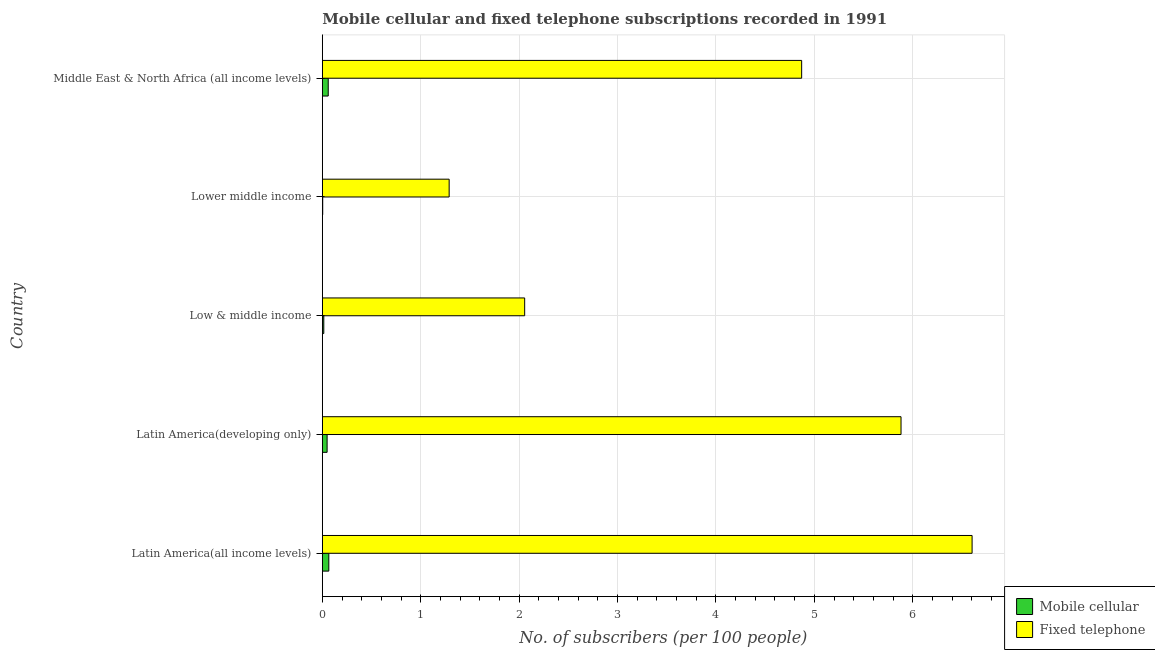How many different coloured bars are there?
Provide a short and direct response. 2. Are the number of bars per tick equal to the number of legend labels?
Provide a succinct answer. Yes. Are the number of bars on each tick of the Y-axis equal?
Provide a short and direct response. Yes. How many bars are there on the 2nd tick from the top?
Keep it short and to the point. 2. What is the label of the 1st group of bars from the top?
Provide a short and direct response. Middle East & North Africa (all income levels). In how many cases, is the number of bars for a given country not equal to the number of legend labels?
Ensure brevity in your answer.  0. What is the number of mobile cellular subscribers in Lower middle income?
Make the answer very short. 0. Across all countries, what is the maximum number of mobile cellular subscribers?
Provide a short and direct response. 0.07. Across all countries, what is the minimum number of mobile cellular subscribers?
Keep it short and to the point. 0. In which country was the number of fixed telephone subscribers maximum?
Give a very brief answer. Latin America(all income levels). In which country was the number of mobile cellular subscribers minimum?
Offer a very short reply. Lower middle income. What is the total number of fixed telephone subscribers in the graph?
Provide a succinct answer. 20.7. What is the difference between the number of mobile cellular subscribers in Latin America(all income levels) and that in Middle East & North Africa (all income levels)?
Your answer should be very brief. 0.01. What is the difference between the number of fixed telephone subscribers in Middle East & North Africa (all income levels) and the number of mobile cellular subscribers in Latin America(all income levels)?
Offer a terse response. 4.81. What is the average number of fixed telephone subscribers per country?
Keep it short and to the point. 4.14. What is the difference between the number of mobile cellular subscribers and number of fixed telephone subscribers in Latin America(all income levels)?
Offer a terse response. -6.54. In how many countries, is the number of fixed telephone subscribers greater than 6 ?
Ensure brevity in your answer.  1. What is the ratio of the number of mobile cellular subscribers in Latin America(developing only) to that in Lower middle income?
Your answer should be very brief. 12.28. Is the difference between the number of mobile cellular subscribers in Low & middle income and Middle East & North Africa (all income levels) greater than the difference between the number of fixed telephone subscribers in Low & middle income and Middle East & North Africa (all income levels)?
Your answer should be compact. Yes. What is the difference between the highest and the second highest number of mobile cellular subscribers?
Offer a terse response. 0.01. In how many countries, is the number of mobile cellular subscribers greater than the average number of mobile cellular subscribers taken over all countries?
Provide a short and direct response. 3. What does the 2nd bar from the top in Latin America(developing only) represents?
Keep it short and to the point. Mobile cellular. What does the 1st bar from the bottom in Low & middle income represents?
Provide a succinct answer. Mobile cellular. How many bars are there?
Provide a succinct answer. 10. What is the difference between two consecutive major ticks on the X-axis?
Keep it short and to the point. 1. Are the values on the major ticks of X-axis written in scientific E-notation?
Ensure brevity in your answer.  No. Where does the legend appear in the graph?
Make the answer very short. Bottom right. What is the title of the graph?
Offer a very short reply. Mobile cellular and fixed telephone subscriptions recorded in 1991. Does "Researchers" appear as one of the legend labels in the graph?
Your answer should be compact. No. What is the label or title of the X-axis?
Provide a short and direct response. No. of subscribers (per 100 people). What is the No. of subscribers (per 100 people) in Mobile cellular in Latin America(all income levels)?
Offer a very short reply. 0.07. What is the No. of subscribers (per 100 people) in Fixed telephone in Latin America(all income levels)?
Give a very brief answer. 6.6. What is the No. of subscribers (per 100 people) of Mobile cellular in Latin America(developing only)?
Provide a succinct answer. 0.05. What is the No. of subscribers (per 100 people) of Fixed telephone in Latin America(developing only)?
Ensure brevity in your answer.  5.88. What is the No. of subscribers (per 100 people) in Mobile cellular in Low & middle income?
Make the answer very short. 0.01. What is the No. of subscribers (per 100 people) in Fixed telephone in Low & middle income?
Provide a short and direct response. 2.06. What is the No. of subscribers (per 100 people) in Mobile cellular in Lower middle income?
Your response must be concise. 0. What is the No. of subscribers (per 100 people) in Fixed telephone in Lower middle income?
Make the answer very short. 1.29. What is the No. of subscribers (per 100 people) in Mobile cellular in Middle East & North Africa (all income levels)?
Your answer should be very brief. 0.06. What is the No. of subscribers (per 100 people) in Fixed telephone in Middle East & North Africa (all income levels)?
Offer a very short reply. 4.87. Across all countries, what is the maximum No. of subscribers (per 100 people) in Mobile cellular?
Your response must be concise. 0.07. Across all countries, what is the maximum No. of subscribers (per 100 people) in Fixed telephone?
Offer a very short reply. 6.6. Across all countries, what is the minimum No. of subscribers (per 100 people) of Mobile cellular?
Keep it short and to the point. 0. Across all countries, what is the minimum No. of subscribers (per 100 people) in Fixed telephone?
Give a very brief answer. 1.29. What is the total No. of subscribers (per 100 people) in Mobile cellular in the graph?
Make the answer very short. 0.19. What is the total No. of subscribers (per 100 people) of Fixed telephone in the graph?
Offer a terse response. 20.7. What is the difference between the No. of subscribers (per 100 people) in Mobile cellular in Latin America(all income levels) and that in Latin America(developing only)?
Your response must be concise. 0.02. What is the difference between the No. of subscribers (per 100 people) in Fixed telephone in Latin America(all income levels) and that in Latin America(developing only)?
Provide a short and direct response. 0.72. What is the difference between the No. of subscribers (per 100 people) in Mobile cellular in Latin America(all income levels) and that in Low & middle income?
Offer a very short reply. 0.05. What is the difference between the No. of subscribers (per 100 people) in Fixed telephone in Latin America(all income levels) and that in Low & middle income?
Provide a succinct answer. 4.55. What is the difference between the No. of subscribers (per 100 people) in Mobile cellular in Latin America(all income levels) and that in Lower middle income?
Your response must be concise. 0.06. What is the difference between the No. of subscribers (per 100 people) of Fixed telephone in Latin America(all income levels) and that in Lower middle income?
Ensure brevity in your answer.  5.31. What is the difference between the No. of subscribers (per 100 people) of Mobile cellular in Latin America(all income levels) and that in Middle East & North Africa (all income levels)?
Keep it short and to the point. 0.01. What is the difference between the No. of subscribers (per 100 people) in Fixed telephone in Latin America(all income levels) and that in Middle East & North Africa (all income levels)?
Give a very brief answer. 1.73. What is the difference between the No. of subscribers (per 100 people) in Mobile cellular in Latin America(developing only) and that in Low & middle income?
Keep it short and to the point. 0.03. What is the difference between the No. of subscribers (per 100 people) in Fixed telephone in Latin America(developing only) and that in Low & middle income?
Your answer should be compact. 3.82. What is the difference between the No. of subscribers (per 100 people) in Mobile cellular in Latin America(developing only) and that in Lower middle income?
Give a very brief answer. 0.04. What is the difference between the No. of subscribers (per 100 people) of Fixed telephone in Latin America(developing only) and that in Lower middle income?
Your response must be concise. 4.59. What is the difference between the No. of subscribers (per 100 people) in Mobile cellular in Latin America(developing only) and that in Middle East & North Africa (all income levels)?
Your response must be concise. -0.01. What is the difference between the No. of subscribers (per 100 people) of Fixed telephone in Latin America(developing only) and that in Middle East & North Africa (all income levels)?
Provide a short and direct response. 1.01. What is the difference between the No. of subscribers (per 100 people) in Mobile cellular in Low & middle income and that in Lower middle income?
Give a very brief answer. 0.01. What is the difference between the No. of subscribers (per 100 people) of Fixed telephone in Low & middle income and that in Lower middle income?
Offer a terse response. 0.77. What is the difference between the No. of subscribers (per 100 people) of Mobile cellular in Low & middle income and that in Middle East & North Africa (all income levels)?
Make the answer very short. -0.05. What is the difference between the No. of subscribers (per 100 people) in Fixed telephone in Low & middle income and that in Middle East & North Africa (all income levels)?
Offer a terse response. -2.81. What is the difference between the No. of subscribers (per 100 people) of Mobile cellular in Lower middle income and that in Middle East & North Africa (all income levels)?
Provide a succinct answer. -0.06. What is the difference between the No. of subscribers (per 100 people) of Fixed telephone in Lower middle income and that in Middle East & North Africa (all income levels)?
Your response must be concise. -3.58. What is the difference between the No. of subscribers (per 100 people) of Mobile cellular in Latin America(all income levels) and the No. of subscribers (per 100 people) of Fixed telephone in Latin America(developing only)?
Your response must be concise. -5.82. What is the difference between the No. of subscribers (per 100 people) in Mobile cellular in Latin America(all income levels) and the No. of subscribers (per 100 people) in Fixed telephone in Low & middle income?
Make the answer very short. -1.99. What is the difference between the No. of subscribers (per 100 people) of Mobile cellular in Latin America(all income levels) and the No. of subscribers (per 100 people) of Fixed telephone in Lower middle income?
Offer a very short reply. -1.22. What is the difference between the No. of subscribers (per 100 people) of Mobile cellular in Latin America(all income levels) and the No. of subscribers (per 100 people) of Fixed telephone in Middle East & North Africa (all income levels)?
Make the answer very short. -4.81. What is the difference between the No. of subscribers (per 100 people) of Mobile cellular in Latin America(developing only) and the No. of subscribers (per 100 people) of Fixed telephone in Low & middle income?
Offer a very short reply. -2.01. What is the difference between the No. of subscribers (per 100 people) in Mobile cellular in Latin America(developing only) and the No. of subscribers (per 100 people) in Fixed telephone in Lower middle income?
Make the answer very short. -1.24. What is the difference between the No. of subscribers (per 100 people) in Mobile cellular in Latin America(developing only) and the No. of subscribers (per 100 people) in Fixed telephone in Middle East & North Africa (all income levels)?
Make the answer very short. -4.82. What is the difference between the No. of subscribers (per 100 people) in Mobile cellular in Low & middle income and the No. of subscribers (per 100 people) in Fixed telephone in Lower middle income?
Ensure brevity in your answer.  -1.27. What is the difference between the No. of subscribers (per 100 people) of Mobile cellular in Low & middle income and the No. of subscribers (per 100 people) of Fixed telephone in Middle East & North Africa (all income levels)?
Ensure brevity in your answer.  -4.86. What is the difference between the No. of subscribers (per 100 people) of Mobile cellular in Lower middle income and the No. of subscribers (per 100 people) of Fixed telephone in Middle East & North Africa (all income levels)?
Your response must be concise. -4.87. What is the average No. of subscribers (per 100 people) in Mobile cellular per country?
Provide a succinct answer. 0.04. What is the average No. of subscribers (per 100 people) in Fixed telephone per country?
Your answer should be very brief. 4.14. What is the difference between the No. of subscribers (per 100 people) of Mobile cellular and No. of subscribers (per 100 people) of Fixed telephone in Latin America(all income levels)?
Your answer should be very brief. -6.54. What is the difference between the No. of subscribers (per 100 people) in Mobile cellular and No. of subscribers (per 100 people) in Fixed telephone in Latin America(developing only)?
Ensure brevity in your answer.  -5.83. What is the difference between the No. of subscribers (per 100 people) of Mobile cellular and No. of subscribers (per 100 people) of Fixed telephone in Low & middle income?
Your response must be concise. -2.04. What is the difference between the No. of subscribers (per 100 people) in Mobile cellular and No. of subscribers (per 100 people) in Fixed telephone in Lower middle income?
Your answer should be very brief. -1.28. What is the difference between the No. of subscribers (per 100 people) of Mobile cellular and No. of subscribers (per 100 people) of Fixed telephone in Middle East & North Africa (all income levels)?
Give a very brief answer. -4.81. What is the ratio of the No. of subscribers (per 100 people) in Mobile cellular in Latin America(all income levels) to that in Latin America(developing only)?
Offer a terse response. 1.36. What is the ratio of the No. of subscribers (per 100 people) of Fixed telephone in Latin America(all income levels) to that in Latin America(developing only)?
Make the answer very short. 1.12. What is the ratio of the No. of subscribers (per 100 people) of Mobile cellular in Latin America(all income levels) to that in Low & middle income?
Your response must be concise. 4.41. What is the ratio of the No. of subscribers (per 100 people) of Fixed telephone in Latin America(all income levels) to that in Low & middle income?
Provide a short and direct response. 3.21. What is the ratio of the No. of subscribers (per 100 people) in Mobile cellular in Latin America(all income levels) to that in Lower middle income?
Ensure brevity in your answer.  16.65. What is the ratio of the No. of subscribers (per 100 people) of Fixed telephone in Latin America(all income levels) to that in Lower middle income?
Provide a short and direct response. 5.12. What is the ratio of the No. of subscribers (per 100 people) in Mobile cellular in Latin America(all income levels) to that in Middle East & North Africa (all income levels)?
Provide a succinct answer. 1.1. What is the ratio of the No. of subscribers (per 100 people) of Fixed telephone in Latin America(all income levels) to that in Middle East & North Africa (all income levels)?
Offer a terse response. 1.36. What is the ratio of the No. of subscribers (per 100 people) in Mobile cellular in Latin America(developing only) to that in Low & middle income?
Offer a very short reply. 3.25. What is the ratio of the No. of subscribers (per 100 people) of Fixed telephone in Latin America(developing only) to that in Low & middle income?
Your answer should be compact. 2.86. What is the ratio of the No. of subscribers (per 100 people) of Mobile cellular in Latin America(developing only) to that in Lower middle income?
Give a very brief answer. 12.28. What is the ratio of the No. of subscribers (per 100 people) in Fixed telephone in Latin America(developing only) to that in Lower middle income?
Ensure brevity in your answer.  4.56. What is the ratio of the No. of subscribers (per 100 people) of Mobile cellular in Latin America(developing only) to that in Middle East & North Africa (all income levels)?
Provide a short and direct response. 0.81. What is the ratio of the No. of subscribers (per 100 people) in Fixed telephone in Latin America(developing only) to that in Middle East & North Africa (all income levels)?
Ensure brevity in your answer.  1.21. What is the ratio of the No. of subscribers (per 100 people) of Mobile cellular in Low & middle income to that in Lower middle income?
Provide a succinct answer. 3.78. What is the ratio of the No. of subscribers (per 100 people) in Fixed telephone in Low & middle income to that in Lower middle income?
Make the answer very short. 1.6. What is the ratio of the No. of subscribers (per 100 people) of Mobile cellular in Low & middle income to that in Middle East & North Africa (all income levels)?
Your answer should be very brief. 0.25. What is the ratio of the No. of subscribers (per 100 people) of Fixed telephone in Low & middle income to that in Middle East & North Africa (all income levels)?
Give a very brief answer. 0.42. What is the ratio of the No. of subscribers (per 100 people) in Mobile cellular in Lower middle income to that in Middle East & North Africa (all income levels)?
Your answer should be very brief. 0.07. What is the ratio of the No. of subscribers (per 100 people) in Fixed telephone in Lower middle income to that in Middle East & North Africa (all income levels)?
Provide a succinct answer. 0.26. What is the difference between the highest and the second highest No. of subscribers (per 100 people) of Mobile cellular?
Make the answer very short. 0.01. What is the difference between the highest and the second highest No. of subscribers (per 100 people) in Fixed telephone?
Provide a succinct answer. 0.72. What is the difference between the highest and the lowest No. of subscribers (per 100 people) in Mobile cellular?
Ensure brevity in your answer.  0.06. What is the difference between the highest and the lowest No. of subscribers (per 100 people) of Fixed telephone?
Provide a succinct answer. 5.31. 